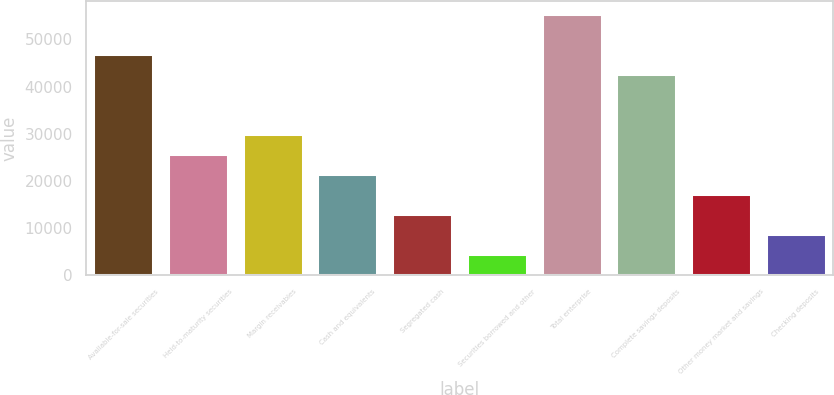Convert chart. <chart><loc_0><loc_0><loc_500><loc_500><bar_chart><fcel>Available-for-sale securities<fcel>Held-to-maturity securities<fcel>Margin receivables<fcel>Cash and equivalents<fcel>Segregated cash<fcel>Securities borrowed and other<fcel>Total enterprise<fcel>Complete savings deposits<fcel>Other money market and savings<fcel>Checking deposits<nl><fcel>46964<fcel>25762<fcel>30002.4<fcel>21521.5<fcel>13040.7<fcel>4559.91<fcel>55444.8<fcel>42723.6<fcel>17281.1<fcel>8800.32<nl></chart> 